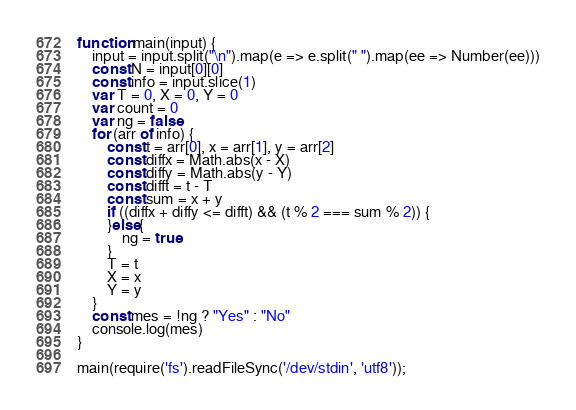Convert code to text. <code><loc_0><loc_0><loc_500><loc_500><_JavaScript_>function main(input) {
    input = input.split("\n").map(e => e.split(" ").map(ee => Number(ee)))
    const N = input[0][0]
    const info = input.slice(1)
    var T = 0, X = 0, Y = 0
    var count = 0
    var ng = false
    for (arr of info) {
        const t = arr[0], x = arr[1], y = arr[2]
        const diffx = Math.abs(x - X)
        const diffy = Math.abs(y - Y)
        const difft = t - T
        const sum = x + y
        if ((diffx + diffy <= difft) && (t % 2 === sum % 2)) {
        }else{
            ng = true
        }
        T = t
        X = x
        Y = y
    }
    const mes = !ng ? "Yes" : "No"
    console.log(mes)
}

main(require('fs').readFileSync('/dev/stdin', 'utf8'));
</code> 